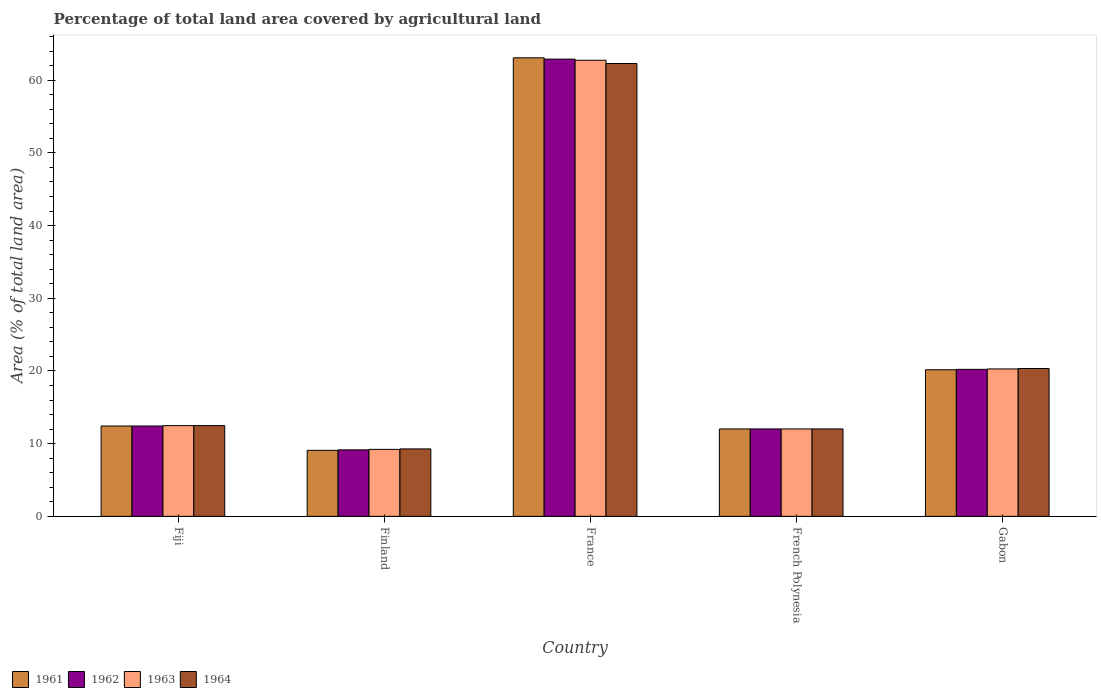Are the number of bars per tick equal to the number of legend labels?
Provide a succinct answer. Yes. In how many cases, is the number of bars for a given country not equal to the number of legend labels?
Keep it short and to the point. 0. What is the percentage of agricultural land in 1963 in Fiji?
Your answer should be compact. 12.48. Across all countries, what is the maximum percentage of agricultural land in 1962?
Provide a succinct answer. 62.9. Across all countries, what is the minimum percentage of agricultural land in 1961?
Provide a succinct answer. 9.08. In which country was the percentage of agricultural land in 1964 maximum?
Make the answer very short. France. What is the total percentage of agricultural land in 1964 in the graph?
Your answer should be very brief. 116.41. What is the difference between the percentage of agricultural land in 1964 in France and that in Gabon?
Provide a succinct answer. 41.96. What is the difference between the percentage of agricultural land in 1964 in Gabon and the percentage of agricultural land in 1962 in Finland?
Make the answer very short. 11.19. What is the average percentage of agricultural land in 1962 per country?
Offer a very short reply. 23.34. What is the difference between the percentage of agricultural land of/in 1963 and percentage of agricultural land of/in 1961 in France?
Your response must be concise. -0.34. What is the ratio of the percentage of agricultural land in 1964 in Fiji to that in France?
Keep it short and to the point. 0.2. Is the difference between the percentage of agricultural land in 1963 in Finland and French Polynesia greater than the difference between the percentage of agricultural land in 1961 in Finland and French Polynesia?
Your answer should be compact. Yes. What is the difference between the highest and the second highest percentage of agricultural land in 1964?
Ensure brevity in your answer.  7.86. What is the difference between the highest and the lowest percentage of agricultural land in 1964?
Your answer should be compact. 53.02. In how many countries, is the percentage of agricultural land in 1962 greater than the average percentage of agricultural land in 1962 taken over all countries?
Offer a terse response. 1. Is the sum of the percentage of agricultural land in 1962 in French Polynesia and Gabon greater than the maximum percentage of agricultural land in 1964 across all countries?
Your answer should be very brief. No. What does the 4th bar from the left in Fiji represents?
Provide a succinct answer. 1964. What does the 4th bar from the right in French Polynesia represents?
Give a very brief answer. 1961. Is it the case that in every country, the sum of the percentage of agricultural land in 1962 and percentage of agricultural land in 1964 is greater than the percentage of agricultural land in 1963?
Your answer should be compact. Yes. How many bars are there?
Offer a very short reply. 20. Are all the bars in the graph horizontal?
Your answer should be compact. No. What is the difference between two consecutive major ticks on the Y-axis?
Keep it short and to the point. 10. Are the values on the major ticks of Y-axis written in scientific E-notation?
Provide a short and direct response. No. Does the graph contain any zero values?
Offer a very short reply. No. How are the legend labels stacked?
Offer a very short reply. Horizontal. What is the title of the graph?
Give a very brief answer. Percentage of total land area covered by agricultural land. What is the label or title of the Y-axis?
Keep it short and to the point. Area (% of total land area). What is the Area (% of total land area) of 1961 in Fiji?
Provide a short and direct response. 12.42. What is the Area (% of total land area) of 1962 in Fiji?
Keep it short and to the point. 12.42. What is the Area (% of total land area) in 1963 in Fiji?
Your answer should be compact. 12.48. What is the Area (% of total land area) of 1964 in Fiji?
Provide a short and direct response. 12.48. What is the Area (% of total land area) in 1961 in Finland?
Ensure brevity in your answer.  9.08. What is the Area (% of total land area) of 1962 in Finland?
Your answer should be compact. 9.14. What is the Area (% of total land area) of 1963 in Finland?
Make the answer very short. 9.21. What is the Area (% of total land area) in 1964 in Finland?
Make the answer very short. 9.28. What is the Area (% of total land area) of 1961 in France?
Your answer should be compact. 63.08. What is the Area (% of total land area) in 1962 in France?
Your answer should be very brief. 62.9. What is the Area (% of total land area) in 1963 in France?
Make the answer very short. 62.74. What is the Area (% of total land area) of 1964 in France?
Ensure brevity in your answer.  62.29. What is the Area (% of total land area) of 1961 in French Polynesia?
Give a very brief answer. 12.02. What is the Area (% of total land area) in 1962 in French Polynesia?
Provide a short and direct response. 12.02. What is the Area (% of total land area) of 1963 in French Polynesia?
Make the answer very short. 12.02. What is the Area (% of total land area) of 1964 in French Polynesia?
Ensure brevity in your answer.  12.02. What is the Area (% of total land area) in 1961 in Gabon?
Ensure brevity in your answer.  20.16. What is the Area (% of total land area) in 1962 in Gabon?
Give a very brief answer. 20.22. What is the Area (% of total land area) in 1963 in Gabon?
Keep it short and to the point. 20.28. What is the Area (% of total land area) of 1964 in Gabon?
Your answer should be very brief. 20.34. Across all countries, what is the maximum Area (% of total land area) in 1961?
Keep it short and to the point. 63.08. Across all countries, what is the maximum Area (% of total land area) in 1962?
Your answer should be very brief. 62.9. Across all countries, what is the maximum Area (% of total land area) in 1963?
Your answer should be compact. 62.74. Across all countries, what is the maximum Area (% of total land area) in 1964?
Keep it short and to the point. 62.29. Across all countries, what is the minimum Area (% of total land area) of 1961?
Provide a short and direct response. 9.08. Across all countries, what is the minimum Area (% of total land area) of 1962?
Keep it short and to the point. 9.14. Across all countries, what is the minimum Area (% of total land area) of 1963?
Make the answer very short. 9.21. Across all countries, what is the minimum Area (% of total land area) of 1964?
Your answer should be compact. 9.28. What is the total Area (% of total land area) in 1961 in the graph?
Provide a succinct answer. 116.77. What is the total Area (% of total land area) in 1962 in the graph?
Offer a terse response. 116.71. What is the total Area (% of total land area) in 1963 in the graph?
Give a very brief answer. 116.73. What is the total Area (% of total land area) of 1964 in the graph?
Keep it short and to the point. 116.41. What is the difference between the Area (% of total land area) in 1961 in Fiji and that in Finland?
Make the answer very short. 3.34. What is the difference between the Area (% of total land area) of 1962 in Fiji and that in Finland?
Provide a succinct answer. 3.28. What is the difference between the Area (% of total land area) in 1963 in Fiji and that in Finland?
Provide a short and direct response. 3.27. What is the difference between the Area (% of total land area) of 1964 in Fiji and that in Finland?
Make the answer very short. 3.2. What is the difference between the Area (% of total land area) of 1961 in Fiji and that in France?
Provide a succinct answer. -50.65. What is the difference between the Area (% of total land area) in 1962 in Fiji and that in France?
Offer a terse response. -50.47. What is the difference between the Area (% of total land area) in 1963 in Fiji and that in France?
Offer a very short reply. -50.26. What is the difference between the Area (% of total land area) of 1964 in Fiji and that in France?
Offer a terse response. -49.81. What is the difference between the Area (% of total land area) of 1961 in Fiji and that in French Polynesia?
Give a very brief answer. 0.4. What is the difference between the Area (% of total land area) in 1962 in Fiji and that in French Polynesia?
Give a very brief answer. 0.4. What is the difference between the Area (% of total land area) in 1963 in Fiji and that in French Polynesia?
Your response must be concise. 0.46. What is the difference between the Area (% of total land area) of 1964 in Fiji and that in French Polynesia?
Offer a very short reply. 0.46. What is the difference between the Area (% of total land area) of 1961 in Fiji and that in Gabon?
Ensure brevity in your answer.  -7.74. What is the difference between the Area (% of total land area) of 1962 in Fiji and that in Gabon?
Provide a succinct answer. -7.79. What is the difference between the Area (% of total land area) of 1963 in Fiji and that in Gabon?
Your response must be concise. -7.8. What is the difference between the Area (% of total land area) in 1964 in Fiji and that in Gabon?
Provide a short and direct response. -7.86. What is the difference between the Area (% of total land area) in 1961 in Finland and that in France?
Your response must be concise. -54. What is the difference between the Area (% of total land area) of 1962 in Finland and that in France?
Make the answer very short. -53.75. What is the difference between the Area (% of total land area) in 1963 in Finland and that in France?
Ensure brevity in your answer.  -53.53. What is the difference between the Area (% of total land area) in 1964 in Finland and that in France?
Provide a succinct answer. -53.02. What is the difference between the Area (% of total land area) in 1961 in Finland and that in French Polynesia?
Keep it short and to the point. -2.94. What is the difference between the Area (% of total land area) in 1962 in Finland and that in French Polynesia?
Your answer should be very brief. -2.88. What is the difference between the Area (% of total land area) in 1963 in Finland and that in French Polynesia?
Offer a very short reply. -2.81. What is the difference between the Area (% of total land area) in 1964 in Finland and that in French Polynesia?
Offer a very short reply. -2.75. What is the difference between the Area (% of total land area) in 1961 in Finland and that in Gabon?
Give a very brief answer. -11.08. What is the difference between the Area (% of total land area) in 1962 in Finland and that in Gabon?
Your answer should be very brief. -11.08. What is the difference between the Area (% of total land area) of 1963 in Finland and that in Gabon?
Offer a very short reply. -11.06. What is the difference between the Area (% of total land area) in 1964 in Finland and that in Gabon?
Your answer should be compact. -11.06. What is the difference between the Area (% of total land area) of 1961 in France and that in French Polynesia?
Offer a very short reply. 51.06. What is the difference between the Area (% of total land area) of 1962 in France and that in French Polynesia?
Offer a terse response. 50.87. What is the difference between the Area (% of total land area) in 1963 in France and that in French Polynesia?
Ensure brevity in your answer.  50.72. What is the difference between the Area (% of total land area) in 1964 in France and that in French Polynesia?
Your answer should be very brief. 50.27. What is the difference between the Area (% of total land area) in 1961 in France and that in Gabon?
Offer a terse response. 42.92. What is the difference between the Area (% of total land area) in 1962 in France and that in Gabon?
Provide a short and direct response. 42.68. What is the difference between the Area (% of total land area) of 1963 in France and that in Gabon?
Ensure brevity in your answer.  42.46. What is the difference between the Area (% of total land area) of 1964 in France and that in Gabon?
Your answer should be very brief. 41.96. What is the difference between the Area (% of total land area) in 1961 in French Polynesia and that in Gabon?
Offer a terse response. -8.14. What is the difference between the Area (% of total land area) in 1962 in French Polynesia and that in Gabon?
Give a very brief answer. -8.2. What is the difference between the Area (% of total land area) of 1963 in French Polynesia and that in Gabon?
Make the answer very short. -8.26. What is the difference between the Area (% of total land area) in 1964 in French Polynesia and that in Gabon?
Keep it short and to the point. -8.31. What is the difference between the Area (% of total land area) in 1961 in Fiji and the Area (% of total land area) in 1962 in Finland?
Your answer should be compact. 3.28. What is the difference between the Area (% of total land area) in 1961 in Fiji and the Area (% of total land area) in 1963 in Finland?
Provide a short and direct response. 3.21. What is the difference between the Area (% of total land area) of 1961 in Fiji and the Area (% of total land area) of 1964 in Finland?
Ensure brevity in your answer.  3.15. What is the difference between the Area (% of total land area) of 1962 in Fiji and the Area (% of total land area) of 1963 in Finland?
Give a very brief answer. 3.21. What is the difference between the Area (% of total land area) in 1962 in Fiji and the Area (% of total land area) in 1964 in Finland?
Make the answer very short. 3.15. What is the difference between the Area (% of total land area) of 1963 in Fiji and the Area (% of total land area) of 1964 in Finland?
Offer a very short reply. 3.2. What is the difference between the Area (% of total land area) of 1961 in Fiji and the Area (% of total land area) of 1962 in France?
Your response must be concise. -50.47. What is the difference between the Area (% of total land area) of 1961 in Fiji and the Area (% of total land area) of 1963 in France?
Make the answer very short. -50.31. What is the difference between the Area (% of total land area) of 1961 in Fiji and the Area (% of total land area) of 1964 in France?
Your response must be concise. -49.87. What is the difference between the Area (% of total land area) in 1962 in Fiji and the Area (% of total land area) in 1963 in France?
Offer a terse response. -50.31. What is the difference between the Area (% of total land area) of 1962 in Fiji and the Area (% of total land area) of 1964 in France?
Give a very brief answer. -49.87. What is the difference between the Area (% of total land area) in 1963 in Fiji and the Area (% of total land area) in 1964 in France?
Your answer should be compact. -49.81. What is the difference between the Area (% of total land area) in 1961 in Fiji and the Area (% of total land area) in 1962 in French Polynesia?
Provide a short and direct response. 0.4. What is the difference between the Area (% of total land area) in 1961 in Fiji and the Area (% of total land area) in 1963 in French Polynesia?
Offer a very short reply. 0.4. What is the difference between the Area (% of total land area) in 1961 in Fiji and the Area (% of total land area) in 1964 in French Polynesia?
Provide a short and direct response. 0.4. What is the difference between the Area (% of total land area) in 1962 in Fiji and the Area (% of total land area) in 1963 in French Polynesia?
Your answer should be very brief. 0.4. What is the difference between the Area (% of total land area) in 1962 in Fiji and the Area (% of total land area) in 1964 in French Polynesia?
Offer a terse response. 0.4. What is the difference between the Area (% of total land area) of 1963 in Fiji and the Area (% of total land area) of 1964 in French Polynesia?
Your response must be concise. 0.46. What is the difference between the Area (% of total land area) in 1961 in Fiji and the Area (% of total land area) in 1962 in Gabon?
Make the answer very short. -7.79. What is the difference between the Area (% of total land area) in 1961 in Fiji and the Area (% of total land area) in 1963 in Gabon?
Provide a succinct answer. -7.85. What is the difference between the Area (% of total land area) in 1961 in Fiji and the Area (% of total land area) in 1964 in Gabon?
Keep it short and to the point. -7.91. What is the difference between the Area (% of total land area) in 1962 in Fiji and the Area (% of total land area) in 1963 in Gabon?
Your response must be concise. -7.85. What is the difference between the Area (% of total land area) in 1962 in Fiji and the Area (% of total land area) in 1964 in Gabon?
Offer a very short reply. -7.91. What is the difference between the Area (% of total land area) of 1963 in Fiji and the Area (% of total land area) of 1964 in Gabon?
Give a very brief answer. -7.86. What is the difference between the Area (% of total land area) in 1961 in Finland and the Area (% of total land area) in 1962 in France?
Offer a terse response. -53.82. What is the difference between the Area (% of total land area) of 1961 in Finland and the Area (% of total land area) of 1963 in France?
Provide a succinct answer. -53.66. What is the difference between the Area (% of total land area) of 1961 in Finland and the Area (% of total land area) of 1964 in France?
Ensure brevity in your answer.  -53.21. What is the difference between the Area (% of total land area) in 1962 in Finland and the Area (% of total land area) in 1963 in France?
Provide a succinct answer. -53.6. What is the difference between the Area (% of total land area) in 1962 in Finland and the Area (% of total land area) in 1964 in France?
Your response must be concise. -53.15. What is the difference between the Area (% of total land area) in 1963 in Finland and the Area (% of total land area) in 1964 in France?
Offer a very short reply. -53.08. What is the difference between the Area (% of total land area) of 1961 in Finland and the Area (% of total land area) of 1962 in French Polynesia?
Keep it short and to the point. -2.94. What is the difference between the Area (% of total land area) in 1961 in Finland and the Area (% of total land area) in 1963 in French Polynesia?
Make the answer very short. -2.94. What is the difference between the Area (% of total land area) in 1961 in Finland and the Area (% of total land area) in 1964 in French Polynesia?
Make the answer very short. -2.94. What is the difference between the Area (% of total land area) of 1962 in Finland and the Area (% of total land area) of 1963 in French Polynesia?
Offer a terse response. -2.88. What is the difference between the Area (% of total land area) of 1962 in Finland and the Area (% of total land area) of 1964 in French Polynesia?
Your response must be concise. -2.88. What is the difference between the Area (% of total land area) of 1963 in Finland and the Area (% of total land area) of 1964 in French Polynesia?
Provide a succinct answer. -2.81. What is the difference between the Area (% of total land area) in 1961 in Finland and the Area (% of total land area) in 1962 in Gabon?
Your response must be concise. -11.14. What is the difference between the Area (% of total land area) in 1961 in Finland and the Area (% of total land area) in 1963 in Gabon?
Your answer should be very brief. -11.2. What is the difference between the Area (% of total land area) of 1961 in Finland and the Area (% of total land area) of 1964 in Gabon?
Provide a short and direct response. -11.26. What is the difference between the Area (% of total land area) in 1962 in Finland and the Area (% of total land area) in 1963 in Gabon?
Your answer should be very brief. -11.13. What is the difference between the Area (% of total land area) in 1962 in Finland and the Area (% of total land area) in 1964 in Gabon?
Offer a very short reply. -11.19. What is the difference between the Area (% of total land area) of 1963 in Finland and the Area (% of total land area) of 1964 in Gabon?
Your answer should be compact. -11.12. What is the difference between the Area (% of total land area) of 1961 in France and the Area (% of total land area) of 1962 in French Polynesia?
Provide a short and direct response. 51.06. What is the difference between the Area (% of total land area) of 1961 in France and the Area (% of total land area) of 1963 in French Polynesia?
Your answer should be compact. 51.06. What is the difference between the Area (% of total land area) of 1961 in France and the Area (% of total land area) of 1964 in French Polynesia?
Your response must be concise. 51.06. What is the difference between the Area (% of total land area) of 1962 in France and the Area (% of total land area) of 1963 in French Polynesia?
Offer a very short reply. 50.87. What is the difference between the Area (% of total land area) of 1962 in France and the Area (% of total land area) of 1964 in French Polynesia?
Offer a terse response. 50.87. What is the difference between the Area (% of total land area) of 1963 in France and the Area (% of total land area) of 1964 in French Polynesia?
Keep it short and to the point. 50.72. What is the difference between the Area (% of total land area) in 1961 in France and the Area (% of total land area) in 1962 in Gabon?
Give a very brief answer. 42.86. What is the difference between the Area (% of total land area) of 1961 in France and the Area (% of total land area) of 1963 in Gabon?
Make the answer very short. 42.8. What is the difference between the Area (% of total land area) of 1961 in France and the Area (% of total land area) of 1964 in Gabon?
Your response must be concise. 42.74. What is the difference between the Area (% of total land area) of 1962 in France and the Area (% of total land area) of 1963 in Gabon?
Your response must be concise. 42.62. What is the difference between the Area (% of total land area) of 1962 in France and the Area (% of total land area) of 1964 in Gabon?
Your answer should be very brief. 42.56. What is the difference between the Area (% of total land area) of 1963 in France and the Area (% of total land area) of 1964 in Gabon?
Give a very brief answer. 42.4. What is the difference between the Area (% of total land area) of 1961 in French Polynesia and the Area (% of total land area) of 1962 in Gabon?
Give a very brief answer. -8.2. What is the difference between the Area (% of total land area) of 1961 in French Polynesia and the Area (% of total land area) of 1963 in Gabon?
Provide a short and direct response. -8.26. What is the difference between the Area (% of total land area) in 1961 in French Polynesia and the Area (% of total land area) in 1964 in Gabon?
Provide a succinct answer. -8.31. What is the difference between the Area (% of total land area) of 1962 in French Polynesia and the Area (% of total land area) of 1963 in Gabon?
Ensure brevity in your answer.  -8.26. What is the difference between the Area (% of total land area) in 1962 in French Polynesia and the Area (% of total land area) in 1964 in Gabon?
Give a very brief answer. -8.31. What is the difference between the Area (% of total land area) of 1963 in French Polynesia and the Area (% of total land area) of 1964 in Gabon?
Ensure brevity in your answer.  -8.31. What is the average Area (% of total land area) of 1961 per country?
Your answer should be compact. 23.35. What is the average Area (% of total land area) in 1962 per country?
Keep it short and to the point. 23.34. What is the average Area (% of total land area) of 1963 per country?
Offer a very short reply. 23.35. What is the average Area (% of total land area) of 1964 per country?
Make the answer very short. 23.28. What is the difference between the Area (% of total land area) in 1961 and Area (% of total land area) in 1962 in Fiji?
Ensure brevity in your answer.  0. What is the difference between the Area (% of total land area) of 1961 and Area (% of total land area) of 1963 in Fiji?
Offer a terse response. -0.05. What is the difference between the Area (% of total land area) in 1961 and Area (% of total land area) in 1964 in Fiji?
Offer a terse response. -0.05. What is the difference between the Area (% of total land area) of 1962 and Area (% of total land area) of 1963 in Fiji?
Offer a terse response. -0.05. What is the difference between the Area (% of total land area) of 1962 and Area (% of total land area) of 1964 in Fiji?
Provide a succinct answer. -0.05. What is the difference between the Area (% of total land area) of 1961 and Area (% of total land area) of 1962 in Finland?
Provide a short and direct response. -0.06. What is the difference between the Area (% of total land area) in 1961 and Area (% of total land area) in 1963 in Finland?
Provide a succinct answer. -0.13. What is the difference between the Area (% of total land area) of 1961 and Area (% of total land area) of 1964 in Finland?
Your response must be concise. -0.2. What is the difference between the Area (% of total land area) of 1962 and Area (% of total land area) of 1963 in Finland?
Provide a short and direct response. -0.07. What is the difference between the Area (% of total land area) of 1962 and Area (% of total land area) of 1964 in Finland?
Make the answer very short. -0.13. What is the difference between the Area (% of total land area) of 1963 and Area (% of total land area) of 1964 in Finland?
Offer a terse response. -0.06. What is the difference between the Area (% of total land area) of 1961 and Area (% of total land area) of 1962 in France?
Offer a terse response. 0.18. What is the difference between the Area (% of total land area) of 1961 and Area (% of total land area) of 1963 in France?
Make the answer very short. 0.34. What is the difference between the Area (% of total land area) in 1961 and Area (% of total land area) in 1964 in France?
Your response must be concise. 0.79. What is the difference between the Area (% of total land area) in 1962 and Area (% of total land area) in 1963 in France?
Ensure brevity in your answer.  0.16. What is the difference between the Area (% of total land area) in 1962 and Area (% of total land area) in 1964 in France?
Provide a succinct answer. 0.6. What is the difference between the Area (% of total land area) of 1963 and Area (% of total land area) of 1964 in France?
Give a very brief answer. 0.45. What is the difference between the Area (% of total land area) in 1961 and Area (% of total land area) in 1962 in French Polynesia?
Make the answer very short. 0. What is the difference between the Area (% of total land area) in 1961 and Area (% of total land area) in 1964 in French Polynesia?
Ensure brevity in your answer.  0. What is the difference between the Area (% of total land area) of 1962 and Area (% of total land area) of 1964 in French Polynesia?
Make the answer very short. 0. What is the difference between the Area (% of total land area) of 1961 and Area (% of total land area) of 1962 in Gabon?
Offer a terse response. -0.06. What is the difference between the Area (% of total land area) in 1961 and Area (% of total land area) in 1963 in Gabon?
Give a very brief answer. -0.12. What is the difference between the Area (% of total land area) of 1961 and Area (% of total land area) of 1964 in Gabon?
Ensure brevity in your answer.  -0.17. What is the difference between the Area (% of total land area) of 1962 and Area (% of total land area) of 1963 in Gabon?
Ensure brevity in your answer.  -0.06. What is the difference between the Area (% of total land area) of 1962 and Area (% of total land area) of 1964 in Gabon?
Your response must be concise. -0.12. What is the difference between the Area (% of total land area) of 1963 and Area (% of total land area) of 1964 in Gabon?
Provide a short and direct response. -0.06. What is the ratio of the Area (% of total land area) in 1961 in Fiji to that in Finland?
Provide a succinct answer. 1.37. What is the ratio of the Area (% of total land area) in 1962 in Fiji to that in Finland?
Provide a succinct answer. 1.36. What is the ratio of the Area (% of total land area) of 1963 in Fiji to that in Finland?
Provide a short and direct response. 1.35. What is the ratio of the Area (% of total land area) in 1964 in Fiji to that in Finland?
Your answer should be compact. 1.35. What is the ratio of the Area (% of total land area) in 1961 in Fiji to that in France?
Make the answer very short. 0.2. What is the ratio of the Area (% of total land area) of 1962 in Fiji to that in France?
Ensure brevity in your answer.  0.2. What is the ratio of the Area (% of total land area) of 1963 in Fiji to that in France?
Make the answer very short. 0.2. What is the ratio of the Area (% of total land area) in 1964 in Fiji to that in France?
Your answer should be compact. 0.2. What is the ratio of the Area (% of total land area) of 1961 in Fiji to that in French Polynesia?
Your response must be concise. 1.03. What is the ratio of the Area (% of total land area) of 1962 in Fiji to that in French Polynesia?
Offer a very short reply. 1.03. What is the ratio of the Area (% of total land area) of 1963 in Fiji to that in French Polynesia?
Provide a succinct answer. 1.04. What is the ratio of the Area (% of total land area) of 1964 in Fiji to that in French Polynesia?
Offer a very short reply. 1.04. What is the ratio of the Area (% of total land area) of 1961 in Fiji to that in Gabon?
Provide a succinct answer. 0.62. What is the ratio of the Area (% of total land area) of 1962 in Fiji to that in Gabon?
Your answer should be compact. 0.61. What is the ratio of the Area (% of total land area) in 1963 in Fiji to that in Gabon?
Keep it short and to the point. 0.62. What is the ratio of the Area (% of total land area) in 1964 in Fiji to that in Gabon?
Offer a terse response. 0.61. What is the ratio of the Area (% of total land area) in 1961 in Finland to that in France?
Your answer should be compact. 0.14. What is the ratio of the Area (% of total land area) of 1962 in Finland to that in France?
Make the answer very short. 0.15. What is the ratio of the Area (% of total land area) in 1963 in Finland to that in France?
Ensure brevity in your answer.  0.15. What is the ratio of the Area (% of total land area) of 1964 in Finland to that in France?
Provide a succinct answer. 0.15. What is the ratio of the Area (% of total land area) of 1961 in Finland to that in French Polynesia?
Your response must be concise. 0.76. What is the ratio of the Area (% of total land area) in 1962 in Finland to that in French Polynesia?
Your answer should be compact. 0.76. What is the ratio of the Area (% of total land area) in 1963 in Finland to that in French Polynesia?
Provide a short and direct response. 0.77. What is the ratio of the Area (% of total land area) in 1964 in Finland to that in French Polynesia?
Keep it short and to the point. 0.77. What is the ratio of the Area (% of total land area) in 1961 in Finland to that in Gabon?
Provide a succinct answer. 0.45. What is the ratio of the Area (% of total land area) of 1962 in Finland to that in Gabon?
Keep it short and to the point. 0.45. What is the ratio of the Area (% of total land area) of 1963 in Finland to that in Gabon?
Offer a terse response. 0.45. What is the ratio of the Area (% of total land area) in 1964 in Finland to that in Gabon?
Your answer should be very brief. 0.46. What is the ratio of the Area (% of total land area) of 1961 in France to that in French Polynesia?
Keep it short and to the point. 5.25. What is the ratio of the Area (% of total land area) in 1962 in France to that in French Polynesia?
Provide a succinct answer. 5.23. What is the ratio of the Area (% of total land area) in 1963 in France to that in French Polynesia?
Ensure brevity in your answer.  5.22. What is the ratio of the Area (% of total land area) in 1964 in France to that in French Polynesia?
Offer a terse response. 5.18. What is the ratio of the Area (% of total land area) in 1961 in France to that in Gabon?
Make the answer very short. 3.13. What is the ratio of the Area (% of total land area) in 1962 in France to that in Gabon?
Your answer should be very brief. 3.11. What is the ratio of the Area (% of total land area) of 1963 in France to that in Gabon?
Provide a short and direct response. 3.09. What is the ratio of the Area (% of total land area) in 1964 in France to that in Gabon?
Offer a very short reply. 3.06. What is the ratio of the Area (% of total land area) in 1961 in French Polynesia to that in Gabon?
Ensure brevity in your answer.  0.6. What is the ratio of the Area (% of total land area) in 1962 in French Polynesia to that in Gabon?
Your answer should be compact. 0.59. What is the ratio of the Area (% of total land area) in 1963 in French Polynesia to that in Gabon?
Make the answer very short. 0.59. What is the ratio of the Area (% of total land area) in 1964 in French Polynesia to that in Gabon?
Provide a short and direct response. 0.59. What is the difference between the highest and the second highest Area (% of total land area) in 1961?
Keep it short and to the point. 42.92. What is the difference between the highest and the second highest Area (% of total land area) in 1962?
Give a very brief answer. 42.68. What is the difference between the highest and the second highest Area (% of total land area) in 1963?
Give a very brief answer. 42.46. What is the difference between the highest and the second highest Area (% of total land area) of 1964?
Ensure brevity in your answer.  41.96. What is the difference between the highest and the lowest Area (% of total land area) of 1961?
Your answer should be compact. 54. What is the difference between the highest and the lowest Area (% of total land area) of 1962?
Ensure brevity in your answer.  53.75. What is the difference between the highest and the lowest Area (% of total land area) of 1963?
Provide a short and direct response. 53.53. What is the difference between the highest and the lowest Area (% of total land area) of 1964?
Provide a succinct answer. 53.02. 